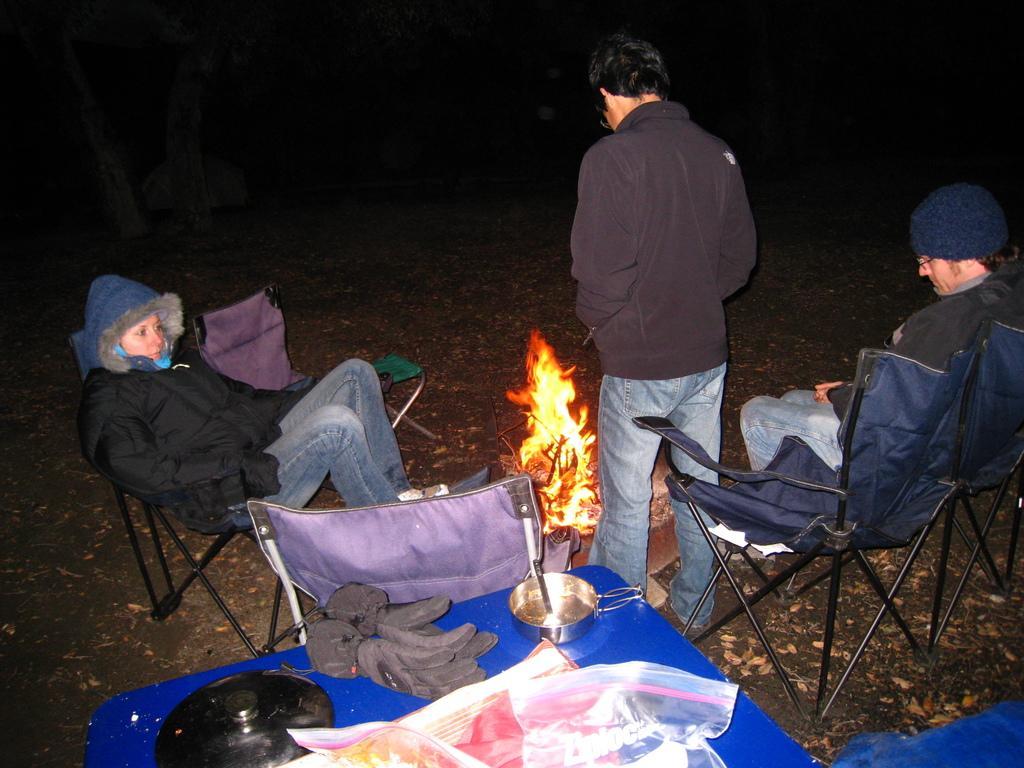How would you summarize this image in a sentence or two? Here in this picture we can see a couple of people sitting on chairs present on the ground over there and we can see another person standing over there, we can see all of them are wearing jackets and caps on them and in the middle we can see a fire place and behind them we can see a table, on which we can see gloves, bowl, a lid and some papers present over there. 